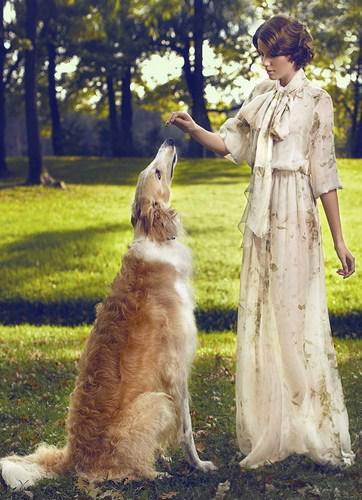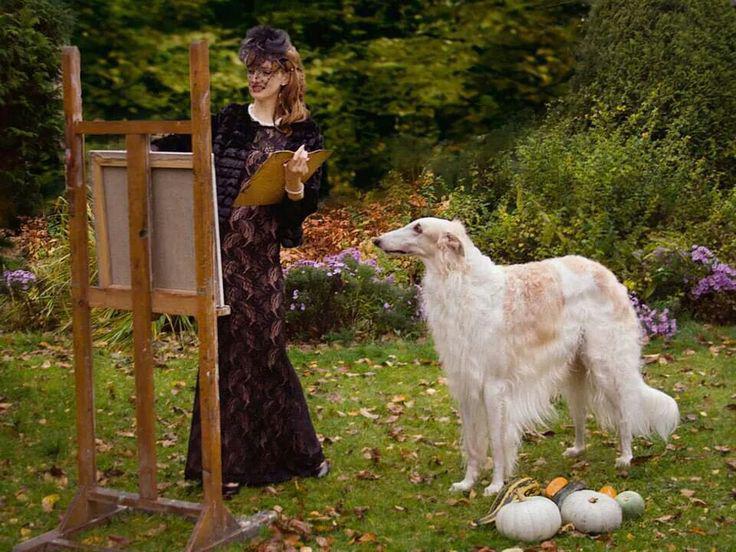The first image is the image on the left, the second image is the image on the right. Analyze the images presented: Is the assertion "There are two women, and each has at least one dog." valid? Answer yes or no. Yes. The first image is the image on the left, the second image is the image on the right. Analyze the images presented: Is the assertion "One of the photos shows two dogs and no people." valid? Answer yes or no. No. 